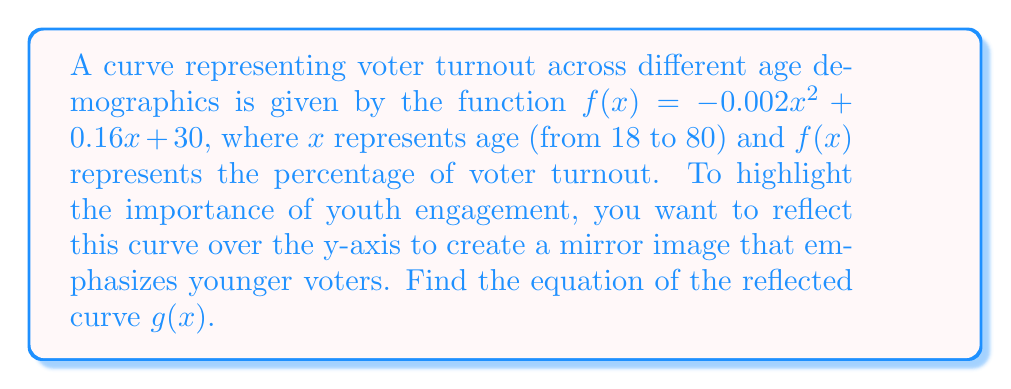Help me with this question. To reflect a curve over the y-axis, we need to replace every $x$ in the original function with $-x$. This transformation can be expressed as $g(x) = f(-x)$.

Let's apply this transformation step-by-step:

1) The original function is:
   $f(x) = -0.002x^2 + 0.16x + 30$

2) Replace every $x$ with $-x$:
   $g(x) = f(-x) = -0.002(-x)^2 + 0.16(-x) + 30$

3) Simplify:
   $g(x) = -0.002x^2 - 0.16x + 30$

   Note that $(-x)^2 = x^2$ because squaring a negative number results in a positive number.

4) The final equation of the reflected curve is:
   $g(x) = -0.002x^2 - 0.16x + 30$

Observe that the coefficient of $x^2$ remains the same, the coefficient of $x$ changes sign, and the constant term stays the same. This is consistent with the general rule for reflecting a quadratic function $f(x) = ax^2 + bx + c$ over the y-axis, which results in $g(x) = ax^2 - bx + c$.
Answer: $g(x) = -0.002x^2 - 0.16x + 30$ 